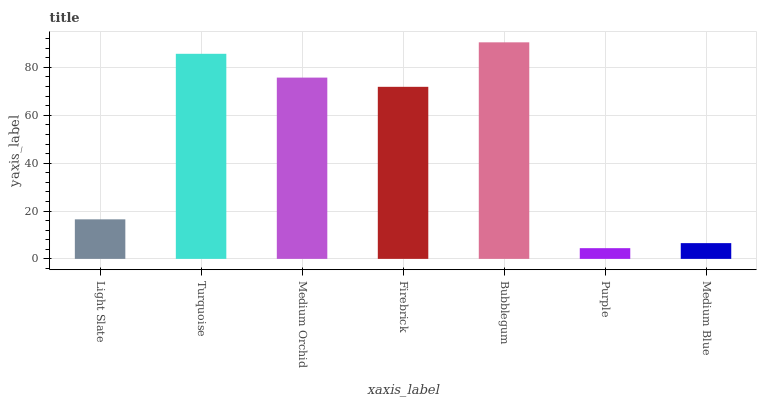Is Turquoise the minimum?
Answer yes or no. No. Is Turquoise the maximum?
Answer yes or no. No. Is Turquoise greater than Light Slate?
Answer yes or no. Yes. Is Light Slate less than Turquoise?
Answer yes or no. Yes. Is Light Slate greater than Turquoise?
Answer yes or no. No. Is Turquoise less than Light Slate?
Answer yes or no. No. Is Firebrick the high median?
Answer yes or no. Yes. Is Firebrick the low median?
Answer yes or no. Yes. Is Turquoise the high median?
Answer yes or no. No. Is Medium Orchid the low median?
Answer yes or no. No. 